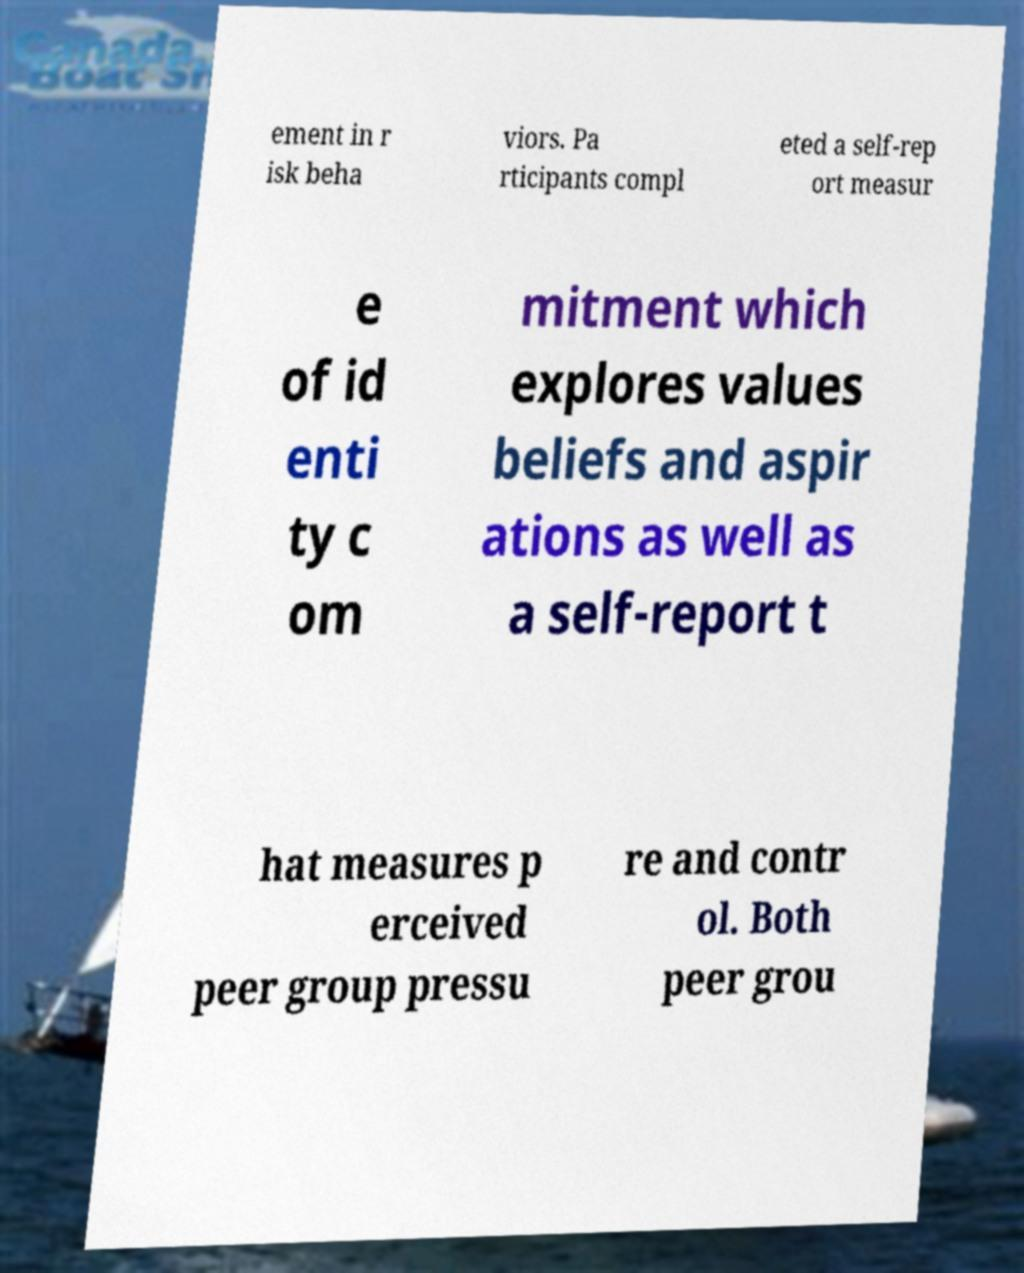I need the written content from this picture converted into text. Can you do that? ement in r isk beha viors. Pa rticipants compl eted a self-rep ort measur e of id enti ty c om mitment which explores values beliefs and aspir ations as well as a self-report t hat measures p erceived peer group pressu re and contr ol. Both peer grou 